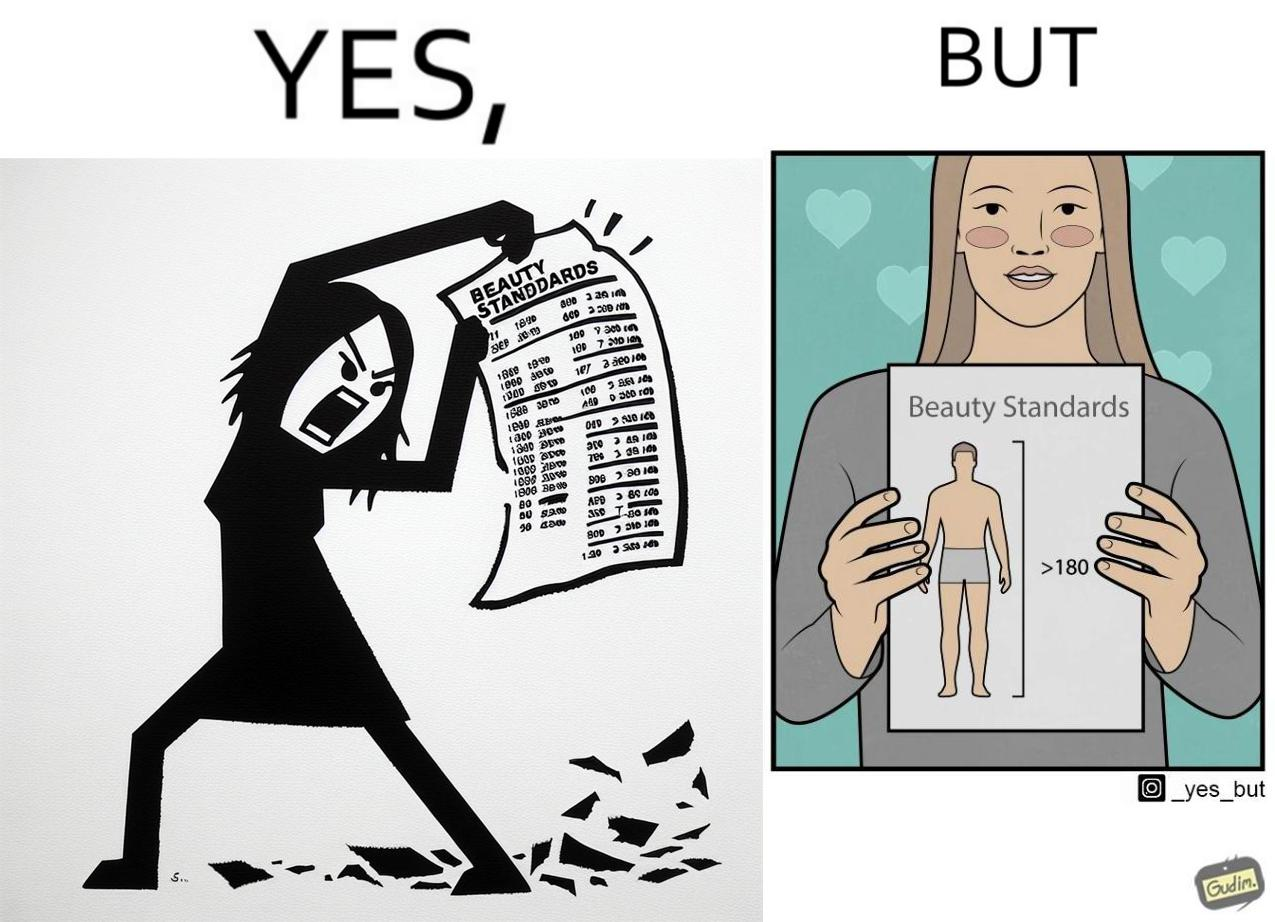Would you classify this image as satirical? Yes, this image is satirical. 